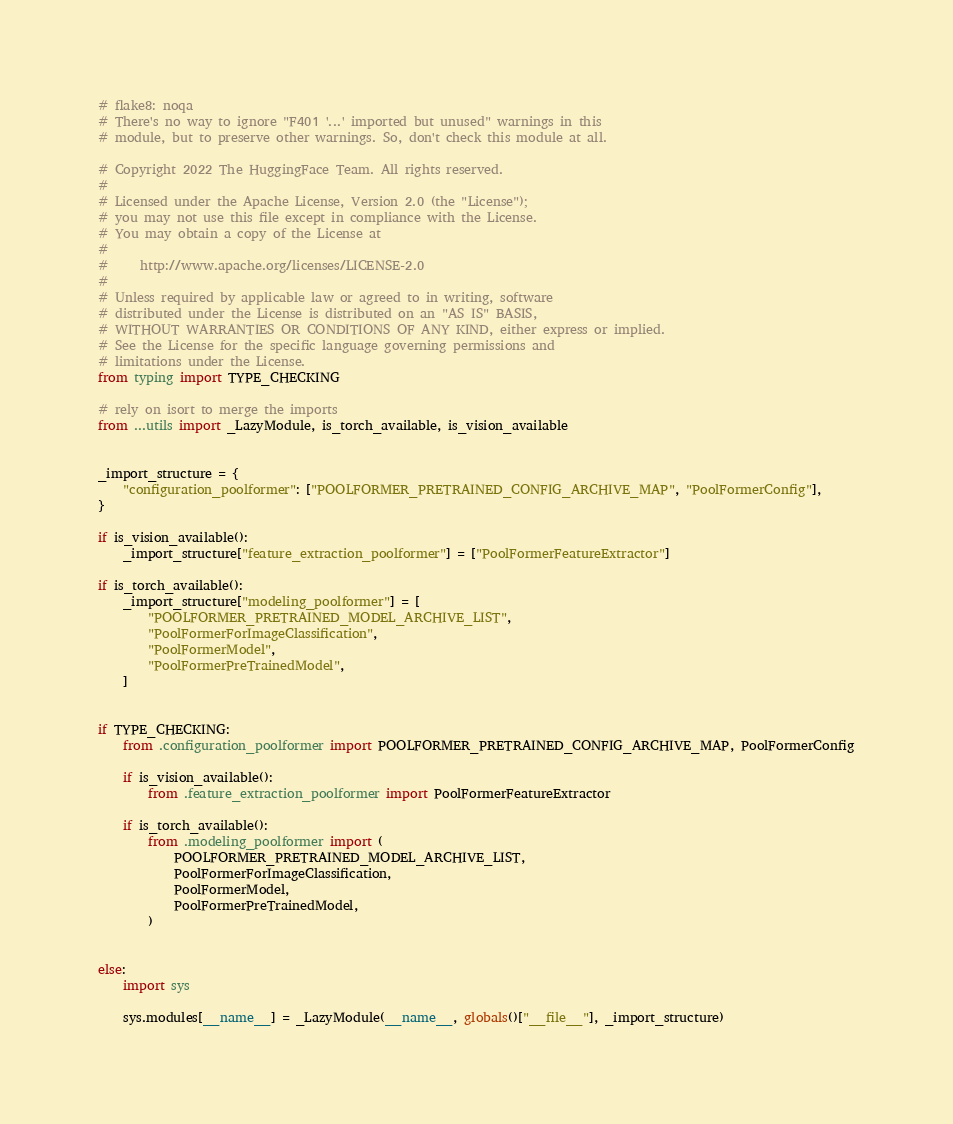Convert code to text. <code><loc_0><loc_0><loc_500><loc_500><_Python_># flake8: noqa
# There's no way to ignore "F401 '...' imported but unused" warnings in this
# module, but to preserve other warnings. So, don't check this module at all.

# Copyright 2022 The HuggingFace Team. All rights reserved.
#
# Licensed under the Apache License, Version 2.0 (the "License");
# you may not use this file except in compliance with the License.
# You may obtain a copy of the License at
#
#     http://www.apache.org/licenses/LICENSE-2.0
#
# Unless required by applicable law or agreed to in writing, software
# distributed under the License is distributed on an "AS IS" BASIS,
# WITHOUT WARRANTIES OR CONDITIONS OF ANY KIND, either express or implied.
# See the License for the specific language governing permissions and
# limitations under the License.
from typing import TYPE_CHECKING

# rely on isort to merge the imports
from ...utils import _LazyModule, is_torch_available, is_vision_available


_import_structure = {
    "configuration_poolformer": ["POOLFORMER_PRETRAINED_CONFIG_ARCHIVE_MAP", "PoolFormerConfig"],
}

if is_vision_available():
    _import_structure["feature_extraction_poolformer"] = ["PoolFormerFeatureExtractor"]

if is_torch_available():
    _import_structure["modeling_poolformer"] = [
        "POOLFORMER_PRETRAINED_MODEL_ARCHIVE_LIST",
        "PoolFormerForImageClassification",
        "PoolFormerModel",
        "PoolFormerPreTrainedModel",
    ]


if TYPE_CHECKING:
    from .configuration_poolformer import POOLFORMER_PRETRAINED_CONFIG_ARCHIVE_MAP, PoolFormerConfig

    if is_vision_available():
        from .feature_extraction_poolformer import PoolFormerFeatureExtractor

    if is_torch_available():
        from .modeling_poolformer import (
            POOLFORMER_PRETRAINED_MODEL_ARCHIVE_LIST,
            PoolFormerForImageClassification,
            PoolFormerModel,
            PoolFormerPreTrainedModel,
        )


else:
    import sys

    sys.modules[__name__] = _LazyModule(__name__, globals()["__file__"], _import_structure)
</code> 